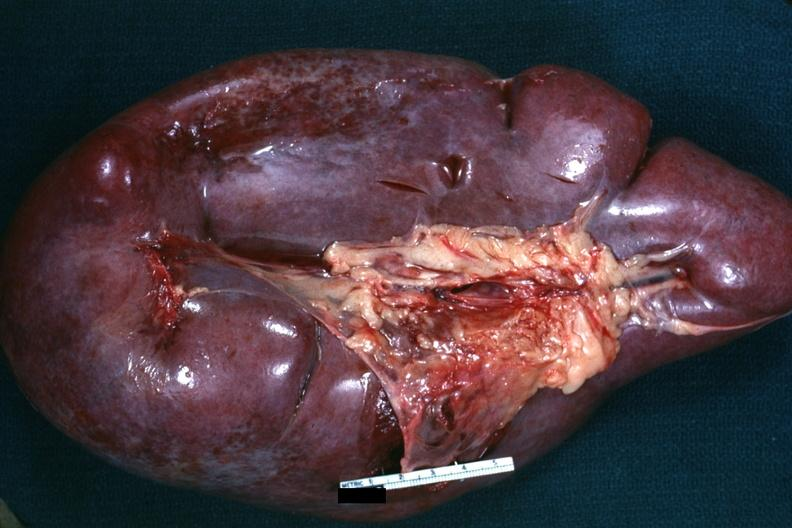what does this image show?
Answer the question using a single word or phrase. External view of massively enlarged spleen 